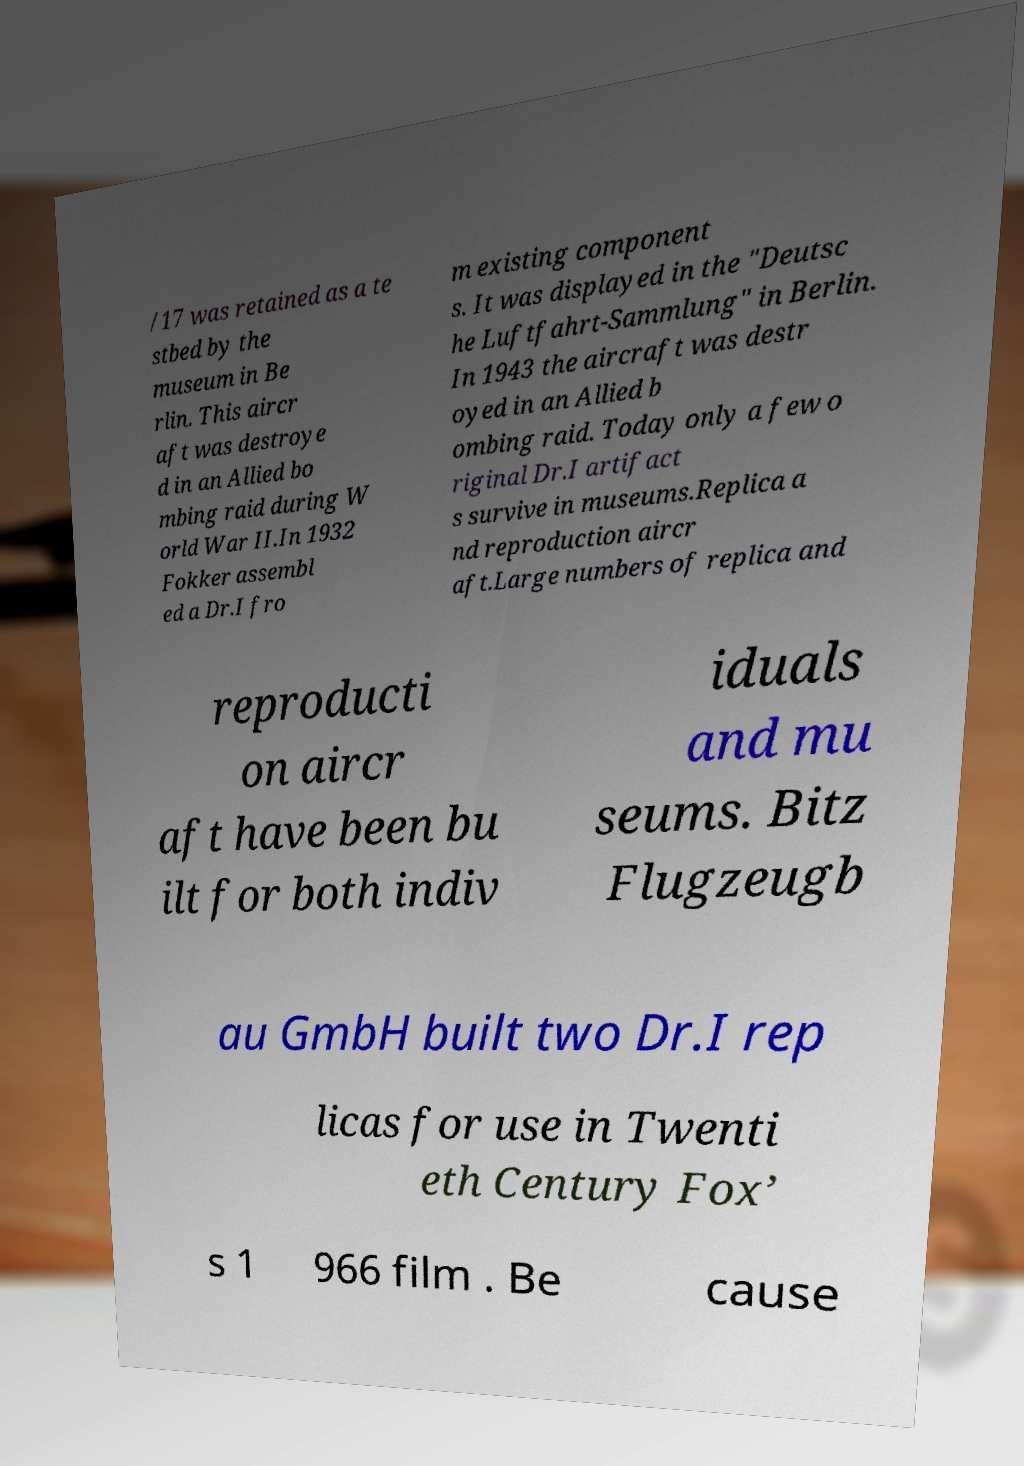There's text embedded in this image that I need extracted. Can you transcribe it verbatim? /17 was retained as a te stbed by the museum in Be rlin. This aircr aft was destroye d in an Allied bo mbing raid during W orld War II.In 1932 Fokker assembl ed a Dr.I fro m existing component s. It was displayed in the "Deutsc he Luftfahrt-Sammlung" in Berlin. In 1943 the aircraft was destr oyed in an Allied b ombing raid. Today only a few o riginal Dr.I artifact s survive in museums.Replica a nd reproduction aircr aft.Large numbers of replica and reproducti on aircr aft have been bu ilt for both indiv iduals and mu seums. Bitz Flugzeugb au GmbH built two Dr.I rep licas for use in Twenti eth Century Fox’ s 1 966 film . Be cause 